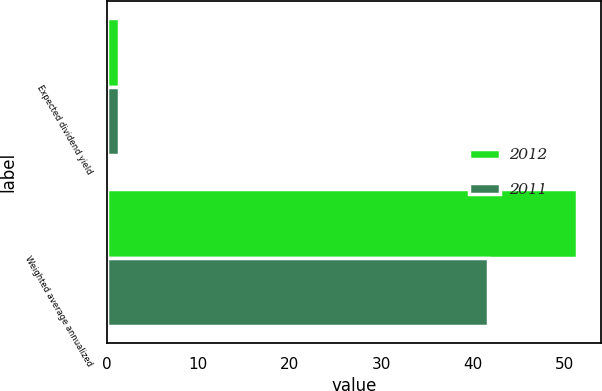Convert chart. <chart><loc_0><loc_0><loc_500><loc_500><stacked_bar_chart><ecel><fcel>Expected dividend yield<fcel>Weighted average annualized<nl><fcel>2012<fcel>1.3<fcel>51.4<nl><fcel>2011<fcel>1.3<fcel>41.7<nl></chart> 